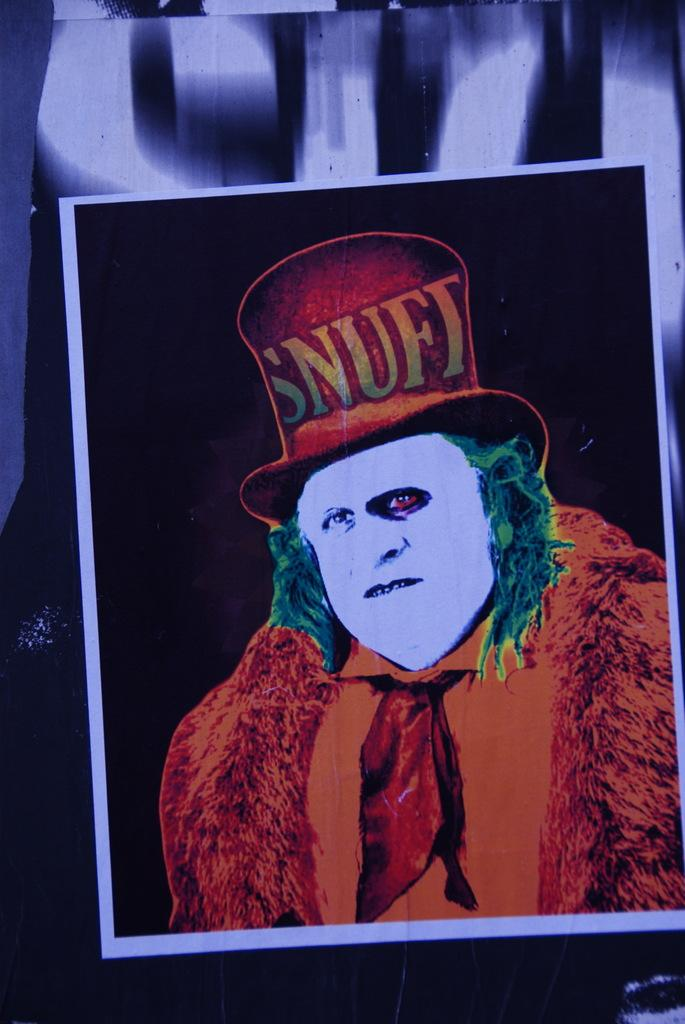What is present in the image? There is a person in the image. What can be observed about the person's face? The person's face is white in color. What is the person wearing? The person is wearing an orange dress. What accessory is on the person's head? There is a hat on the person's head. What is written on the hat? The hat has "snuft" written on it. Can you see any feathers on the person's dress in the image? No, there are no feathers visible on the person's dress in the image. Is there is a match or knife present in the image? No, there is no match or knife present in the image. 